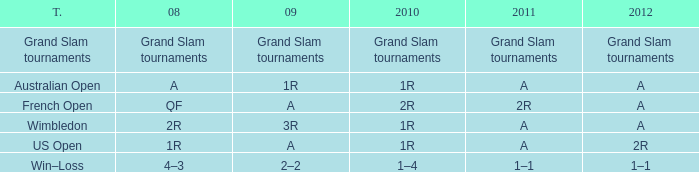Name the 2011 for 2012 of a and 2010 of 1r with 2008 of 2r A. 